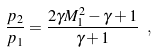Convert formula to latex. <formula><loc_0><loc_0><loc_500><loc_500>\frac { p _ { 2 } } { p _ { 1 } } = \frac { 2 \gamma M _ { 1 } ^ { 2 } - \gamma + 1 } { \gamma + 1 } \ ,</formula> 